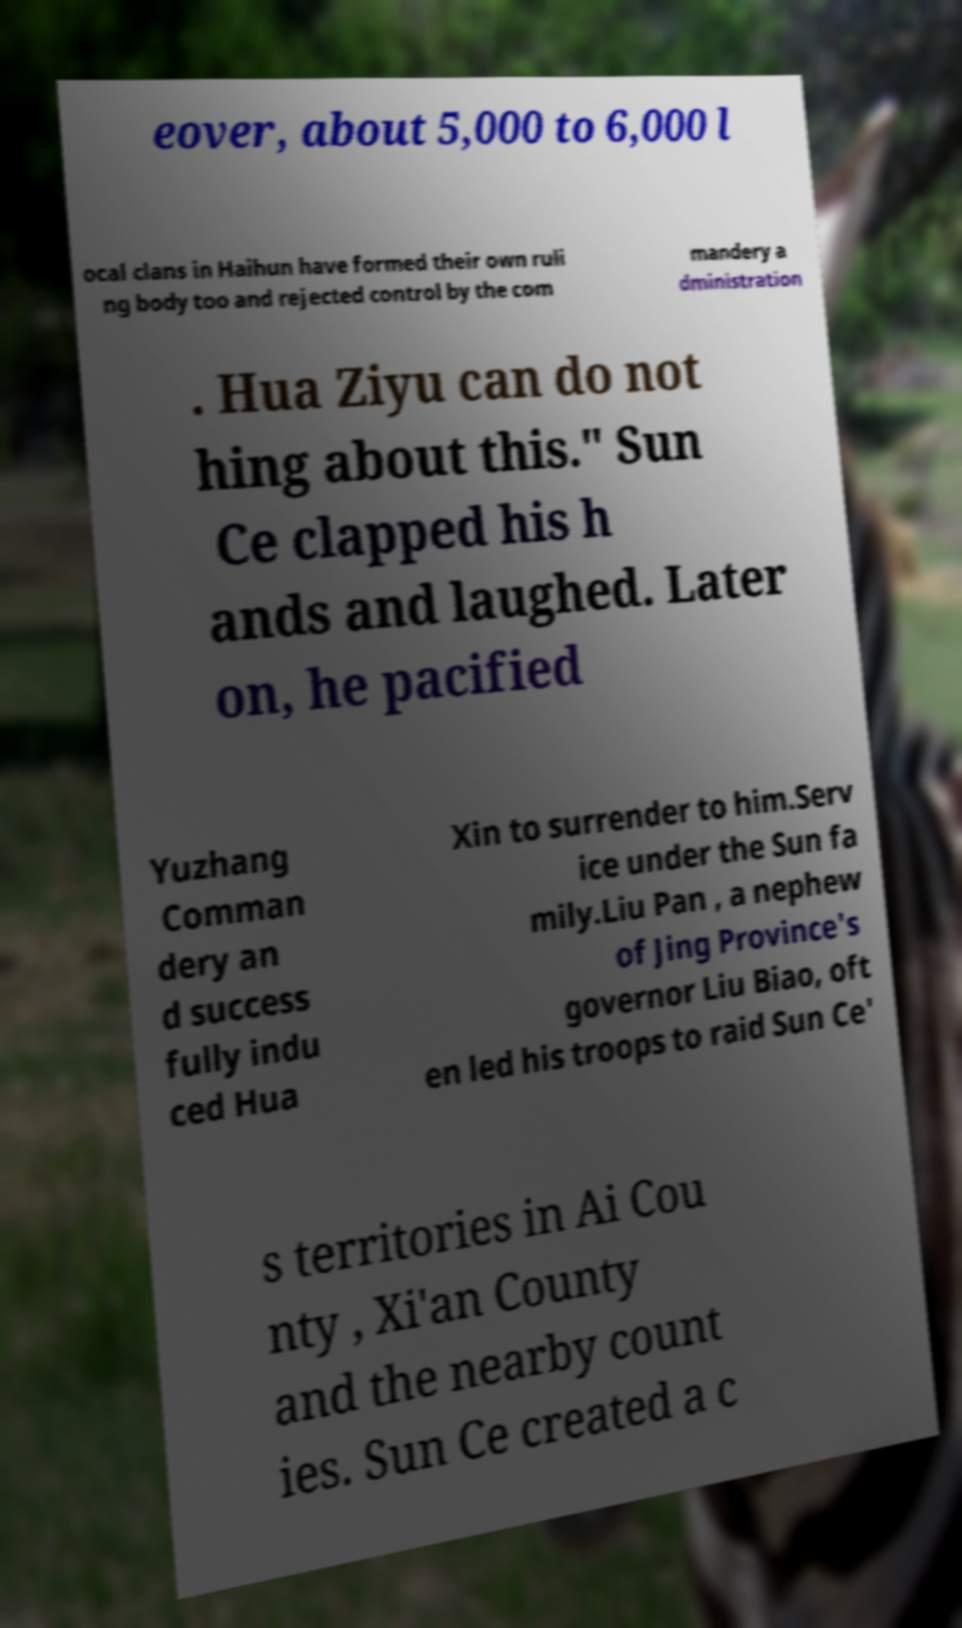Could you extract and type out the text from this image? eover, about 5,000 to 6,000 l ocal clans in Haihun have formed their own ruli ng body too and rejected control by the com mandery a dministration . Hua Ziyu can do not hing about this." Sun Ce clapped his h ands and laughed. Later on, he pacified Yuzhang Comman dery an d success fully indu ced Hua Xin to surrender to him.Serv ice under the Sun fa mily.Liu Pan , a nephew of Jing Province's governor Liu Biao, oft en led his troops to raid Sun Ce' s territories in Ai Cou nty , Xi'an County and the nearby count ies. Sun Ce created a c 